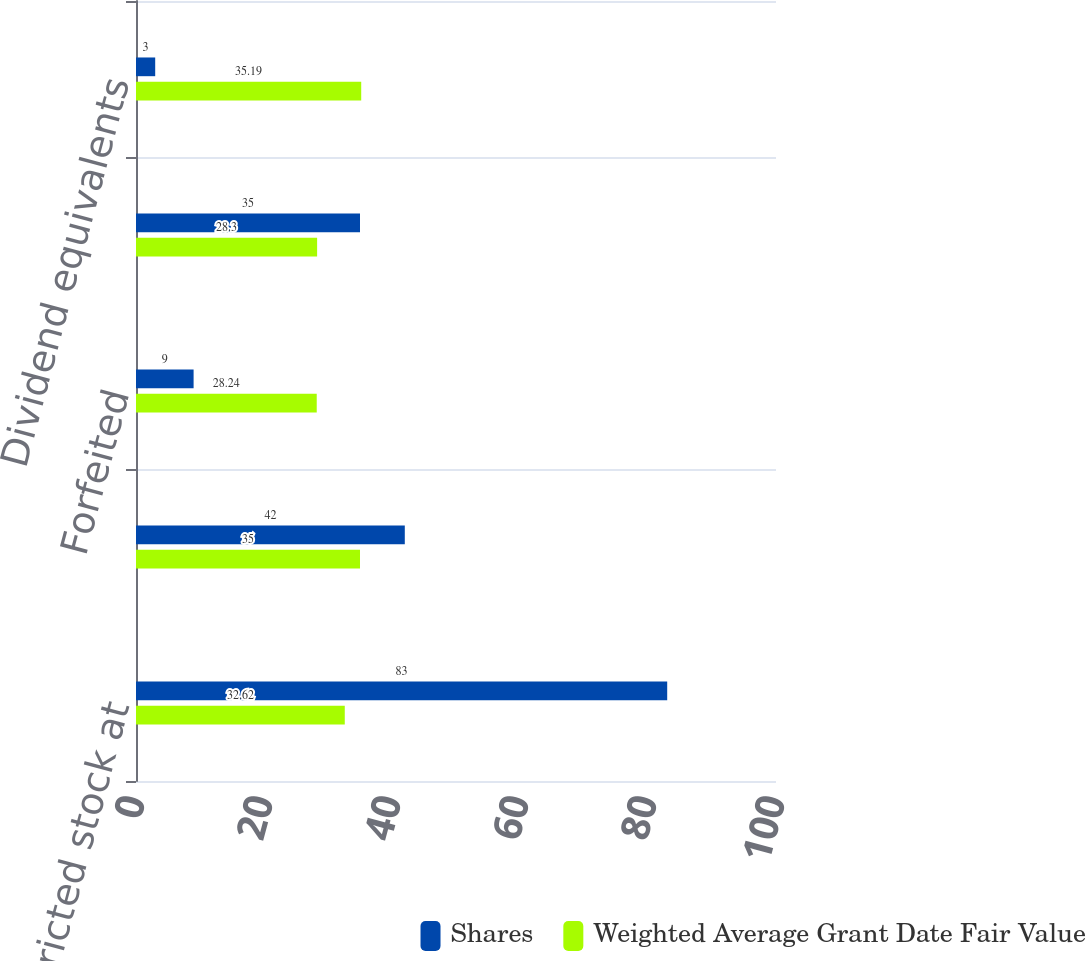<chart> <loc_0><loc_0><loc_500><loc_500><stacked_bar_chart><ecel><fcel>Nonvested restricted stock at<fcel>Granted<fcel>Forfeited<fcel>Vested<fcel>Dividend equivalents<nl><fcel>Shares<fcel>83<fcel>42<fcel>9<fcel>35<fcel>3<nl><fcel>Weighted Average Grant Date Fair Value<fcel>32.62<fcel>35<fcel>28.24<fcel>28.3<fcel>35.19<nl></chart> 